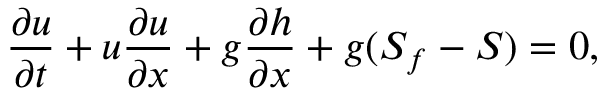Convert formula to latex. <formula><loc_0><loc_0><loc_500><loc_500>{ \frac { \partial u } { \partial t } } + u { \frac { \partial u } { \partial x } } + g { \frac { \partial h } { \partial x } } + g ( S _ { f } - S ) = 0 ,</formula> 